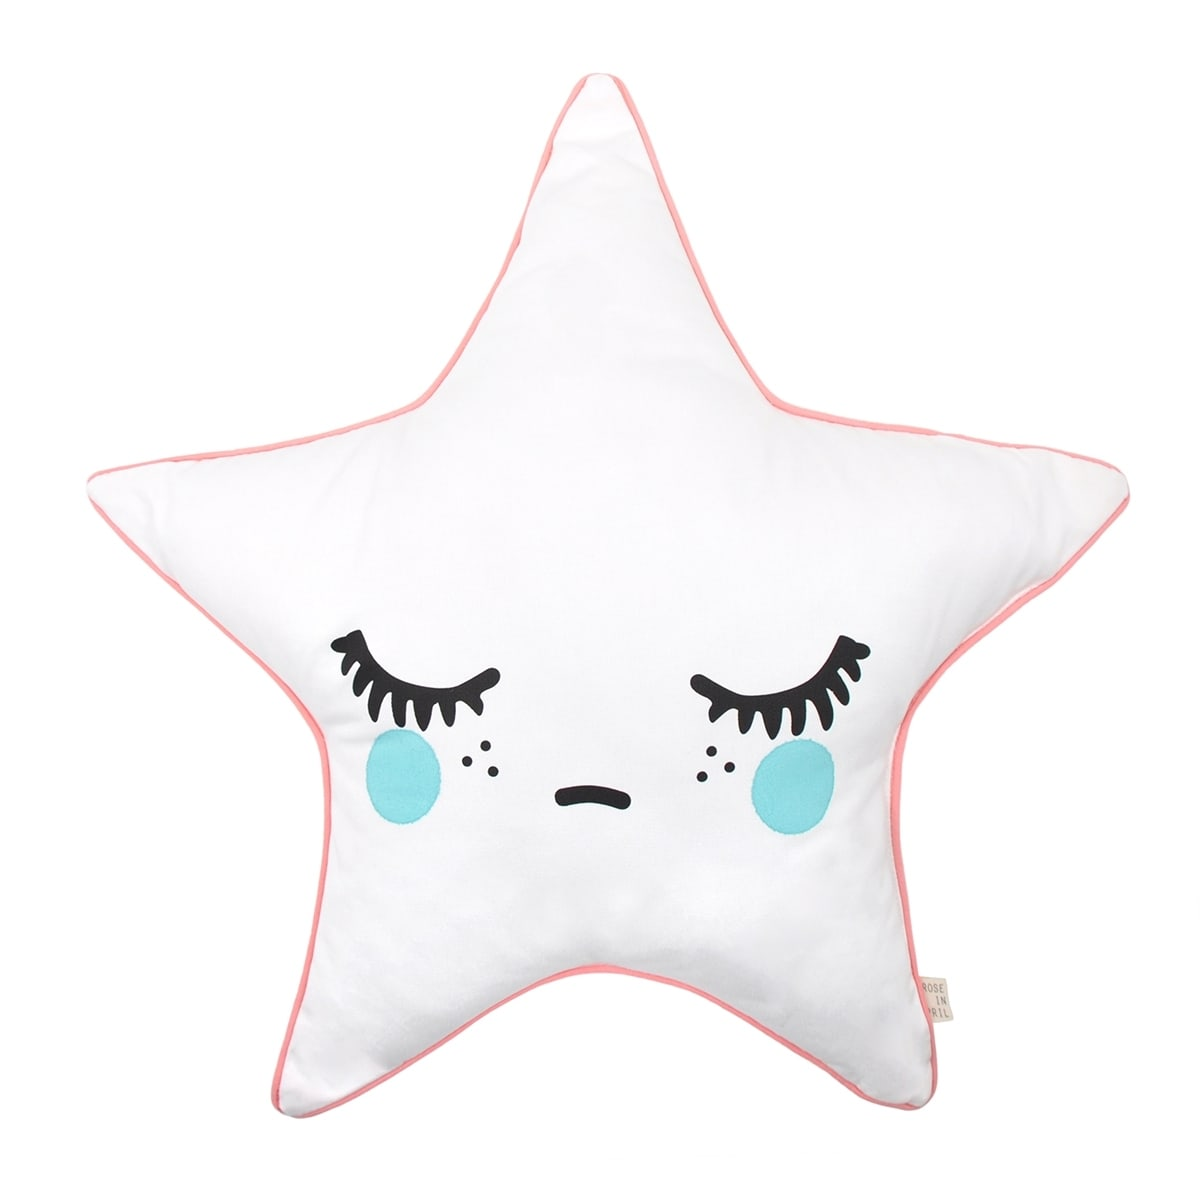What might be the intended use of this pillow based on its design and features? The intended use of this pillow, considering its design and features, appears to serve dual purposes: decorative and comfort-related. The star shape paired with the whimsical, sleepy facial expression suggests that it is designed to captivate children or individuals who appreciate playful and lighthearted home decor. Its plush material further enhances its comfort, making it an ideal addition to a child's bedroom, living room, or a cozy reading nook. While the exact size is not specified, its shape and design imply it could be used for cuddling or as a charming throw pillow on a bed or sofa. Overall, it seems perfect for adding a touch of coziness and charm to various spaces in a home. 